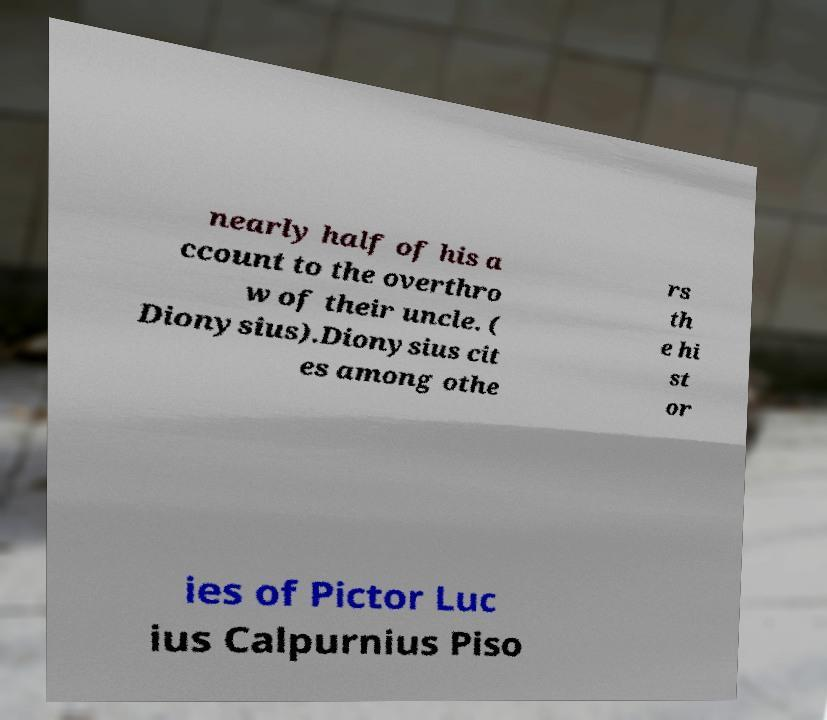What messages or text are displayed in this image? I need them in a readable, typed format. nearly half of his a ccount to the overthro w of their uncle. ( Dionysius).Dionysius cit es among othe rs th e hi st or ies of Pictor Luc ius Calpurnius Piso 